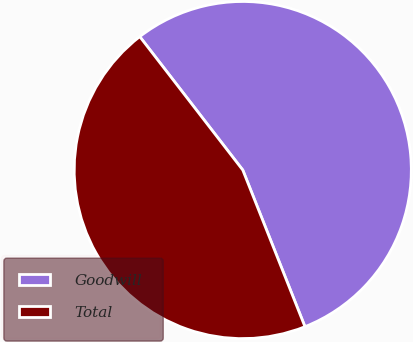<chart> <loc_0><loc_0><loc_500><loc_500><pie_chart><fcel>Goodwill<fcel>Total<nl><fcel>54.45%<fcel>45.55%<nl></chart> 